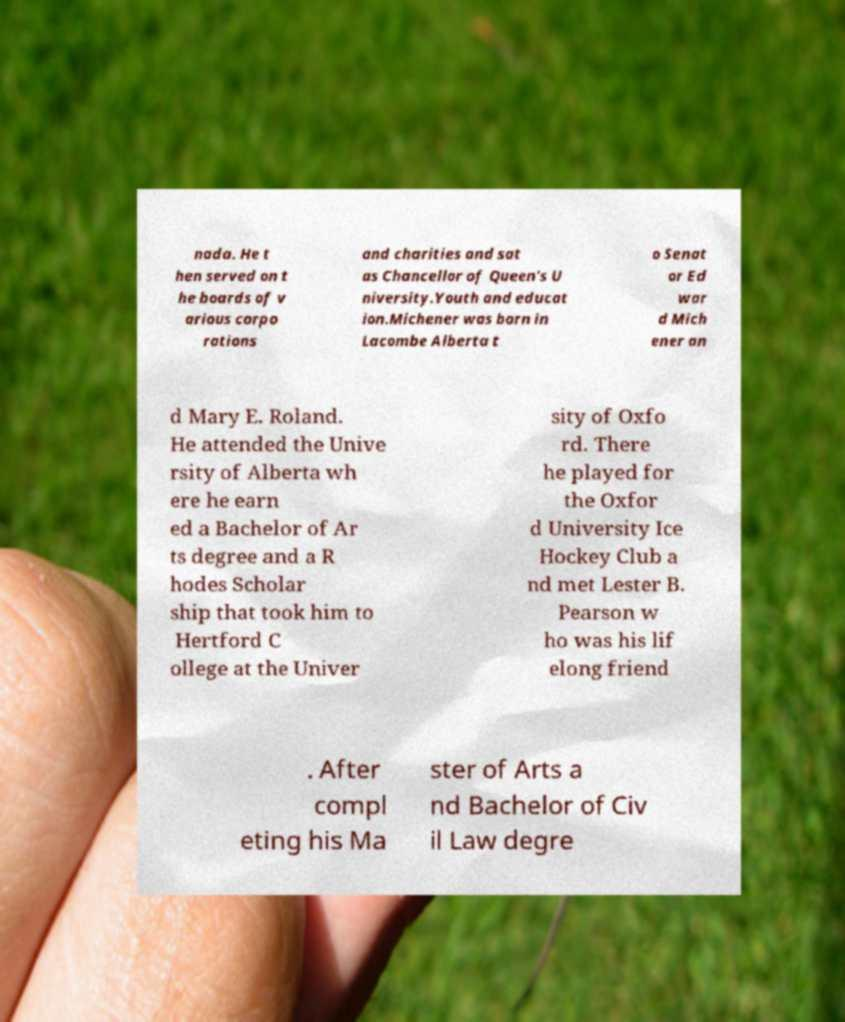For documentation purposes, I need the text within this image transcribed. Could you provide that? nada. He t hen served on t he boards of v arious corpo rations and charities and sat as Chancellor of Queen's U niversity.Youth and educat ion.Michener was born in Lacombe Alberta t o Senat or Ed war d Mich ener an d Mary E. Roland. He attended the Unive rsity of Alberta wh ere he earn ed a Bachelor of Ar ts degree and a R hodes Scholar ship that took him to Hertford C ollege at the Univer sity of Oxfo rd. There he played for the Oxfor d University Ice Hockey Club a nd met Lester B. Pearson w ho was his lif elong friend . After compl eting his Ma ster of Arts a nd Bachelor of Civ il Law degre 